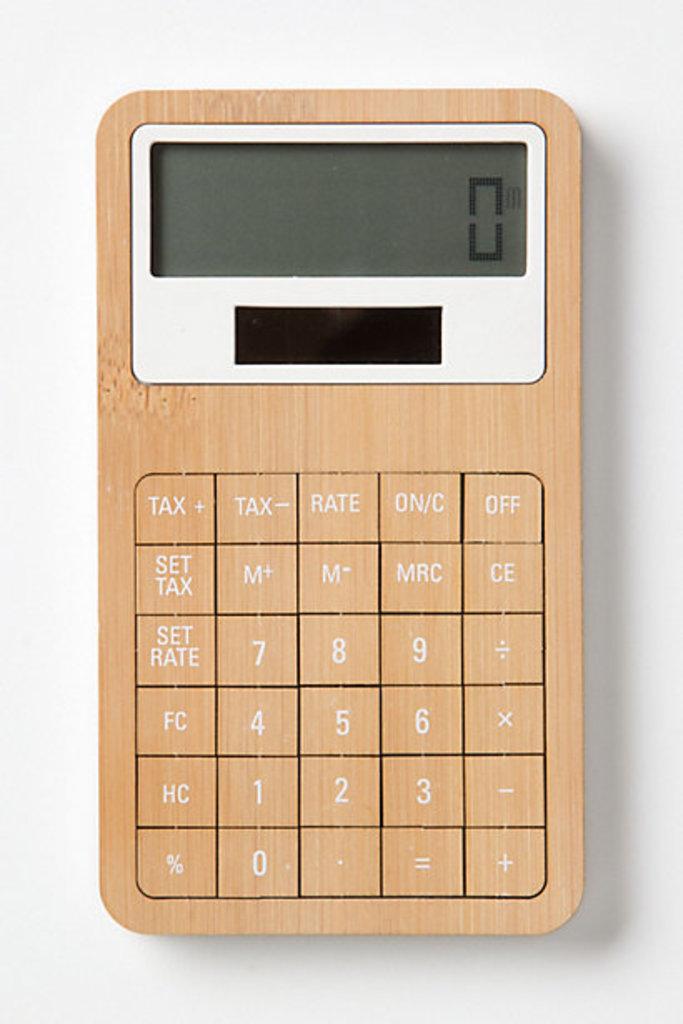What does one of the buttons on this calculator say?
Keep it short and to the point. Rate. What is the top right button for?
Provide a succinct answer. Off. 